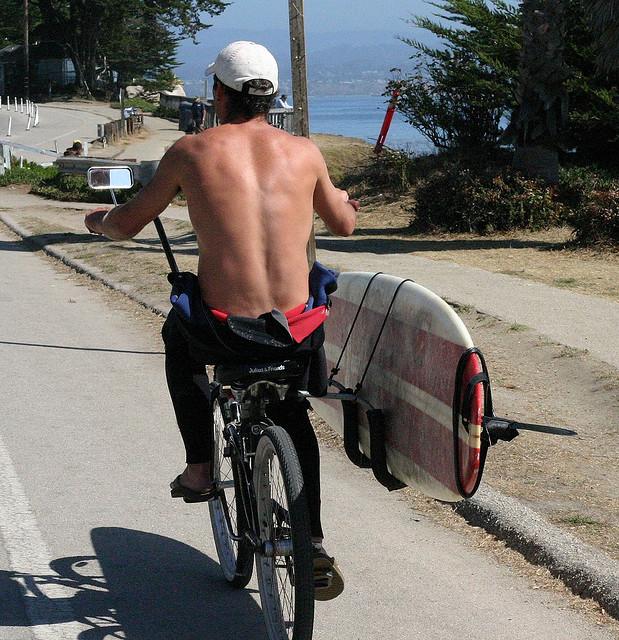Is this man at the beach?
Keep it brief. No. Are there two old ladies at the other end of the sidewalk?
Be succinct. No. How many bicycles are pictured?
Be succinct. 1. Is this person wearing a shirt?
Answer briefly. No. What is the man carrying on his bike?
Quick response, please. Surfboard. 